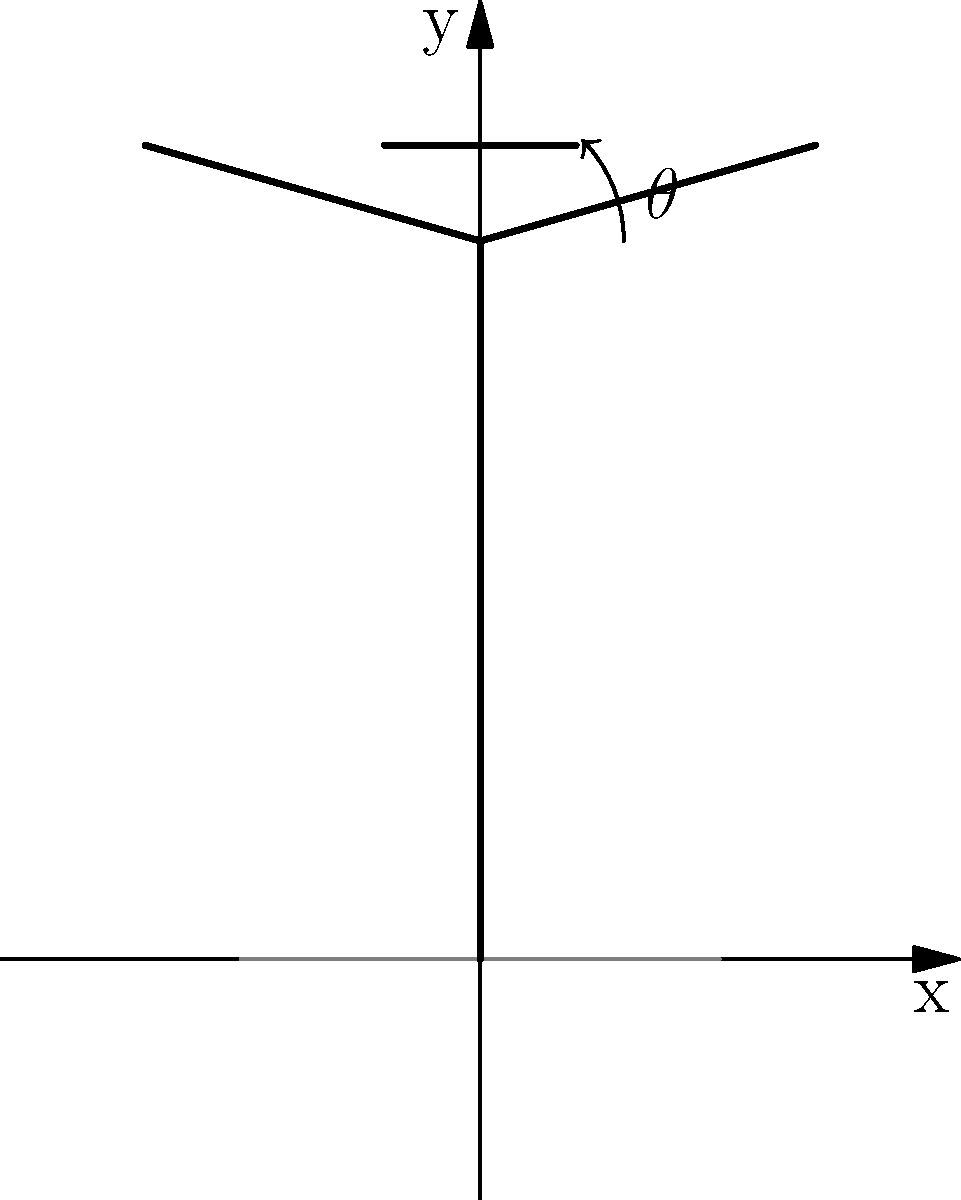A discus thrower is rotating with their arms extended, holding the discus. If the angle $\theta$ between the thrower's arms and the horizontal is 45°, and the thrower completes one full rotation in 0.8 seconds, estimate the angular velocity of the thrower in radians per second. To solve this problem, let's follow these steps:

1) First, recall that angular velocity ($\omega$) is defined as the rate of change of angular position with respect to time. It's measured in radians per second.

2) We're given that the thrower completes one full rotation in 0.8 seconds. One full rotation corresponds to $2\pi$ radians.

3) We can set up the equation:
   
   $\omega = \frac{\text{angular displacement}}{\text{time}}$

4) Substituting the values:

   $\omega = \frac{2\pi \text{ radians}}{0.8 \text{ seconds}}$

5) Simplify:
   
   $\omega = \frac{2\pi}{0.8} = 2.5\pi \approx 7.85 \text{ rad/s}$

Note: The angle $\theta$ given in the question (45°) is not directly used in this calculation. It's more relevant for determining the moment of inertia or the linear velocity at the end of the arms, which aren't asked for in this problem.
Answer: $7.85 \text{ rad/s}$ 